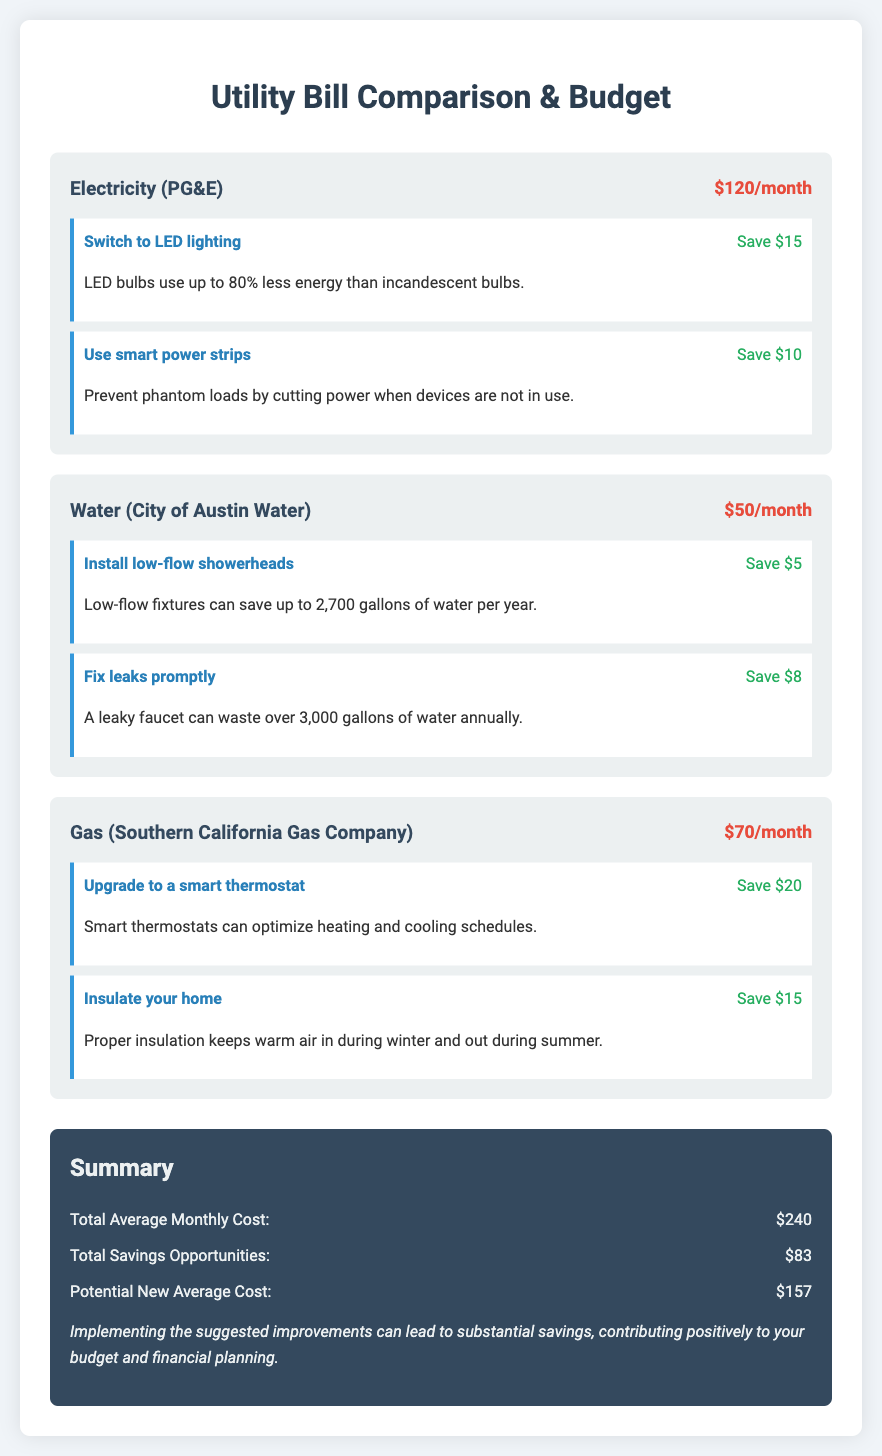What is the total average monthly cost? The total average monthly cost is presented in the summary section of the document. It totals all utility bills as formatted.
Answer: $240 How much can be saved by switching to LED lighting? The savings from switching to LED lighting are listed under the electricity improvement suggestions.
Answer: Save $15 What is the monthly cost of water? The document specifies the monthly cost of water in the utility card section.
Answer: $50 What improvement can save $20 on gas? The improvement that offers this level of savings is mentioned in the gas utility card under the suggestions.
Answer: Upgrade to a smart thermostat What is the potential new average cost after implementing suggested savings? This figure is calculated by subtracting total savings from the average monthly cost, as listed in the summary.
Answer: $157 How much can be saved by fixing leaks promptly? The amount saved by fixing leaks promptly is specified in the water improvements section.
Answer: Save $8 What is the combined total of the water and gas monthly costs? This can be calculated by adding the monthly costs of water and gas presented in their respective utility cards.
Answer: $120 How much can be saved by using smart power strips? The savings from using smart power strips are listed under the electricity improvements in the document.
Answer: Save $10 